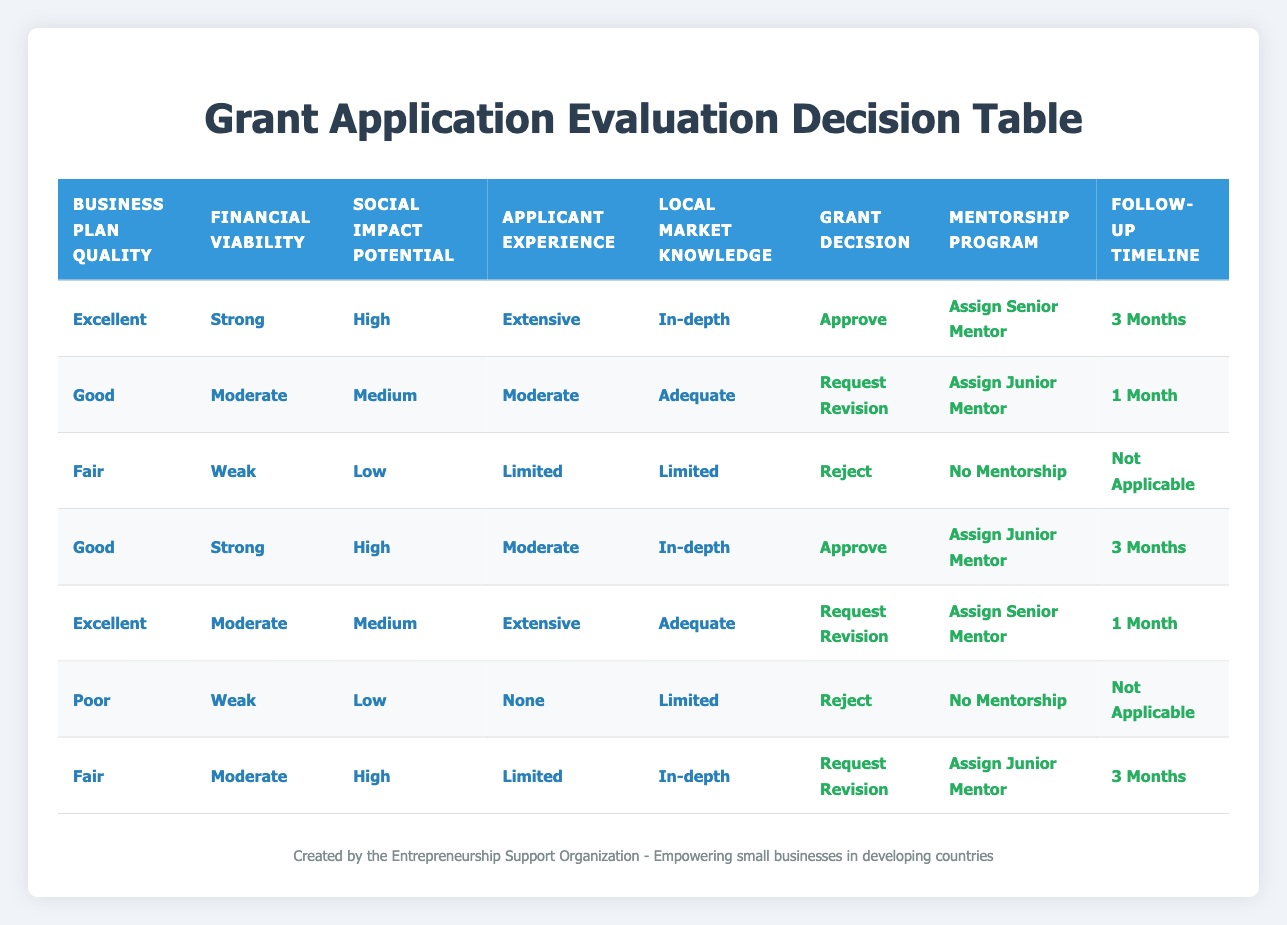What is the grant decision for an application with "Excellent" business plan quality, "Strong" financial viability, "High" social impact potential, "Extensive" applicant experience, and "In-depth" local market knowledge? From the table, this specific combination of conditions corresponds to the first row which states that the grant decision is "Approve".
Answer: Approve How many conditions lead to a "Reject" decision? By scanning the table, there are three rows that indicate a "Reject" decision: one with "Fair" business plan quality and "Weak" financial viability, another with "Poor" business plan quality and "Weak" financial viability, and one with "Limited" applicant experience. Thus, there are three conditions that lead to "Reject".
Answer: 3 Is there a condition where the "Follow-up Timeline" is listed as "Not Applicable"? A quick look at the table reveals that both the "Fair" business plan quality with "Weak" financial viability and "Poor" business plan quality with "Weak" financial viability show "Not Applicable" in the follow-up timeline. Therefore, the answer is yes.
Answer: Yes What are the mentorship program assignments for applications categorized with "Good" business plan quality and "Strong" financial viability? From the second and fourth rows, both categories have a different mentorship assignment: the second row assigns a "Junior Mentor" while the fourth row also assigns a "Junior Mentor". Therefore, the consistent assignment is "Assign Junior Mentor".
Answer: Assign Junior Mentor If an application is "Fair" in business plan quality and has "Moderate" financial viability, what will be the follow-up timeline for the application? Looking at the combination of "Fair" business plan quality and "Moderate" financial viability, the relevant row specifies a follow-up timeline of "3 Months".
Answer: 3 Months How would the outcomes differ in terms of mentorship program assignment for a proposal deemed as "Good" but with either "Moderate" or "Strong" financial viability? Analyzing the second row (Good, Moderate) leads to "Assign Junior Mentor", while the fourth row (Good, Strong) also leads to "Assign Junior Mentor". Therefore, the mentorship program assignment remains the same regardless of financial viability.
Answer: No difference What is the most common follow-up timeline for applications with "Good" business plan quality? The conditions for "Good" business plan quality appear in two rows in the table: the second row has "1 Month" follow-up, and the fourth has "3 Months". Counting the occurrences, "1 Month" and "3 Months" each occur once, meaning there's no clear most common timeline; both timelines are present equally.
Answer: No common timeline Are there any "Excellent" applications that are rejected? Reviewing the table, there are no rows where "Excellent" quality applications result in a rejection. The first and fifth conditions are approvals, confirming that no excellent applications are rejected.
Answer: No What is the social impact potential in the most favorable condition for grant decision? The first row indicates the most favorable conditions for a grant decision are "Excellent", "Strong", "High", "Extensive", and "In-depth", thus the social impact potential here is "High".
Answer: High 